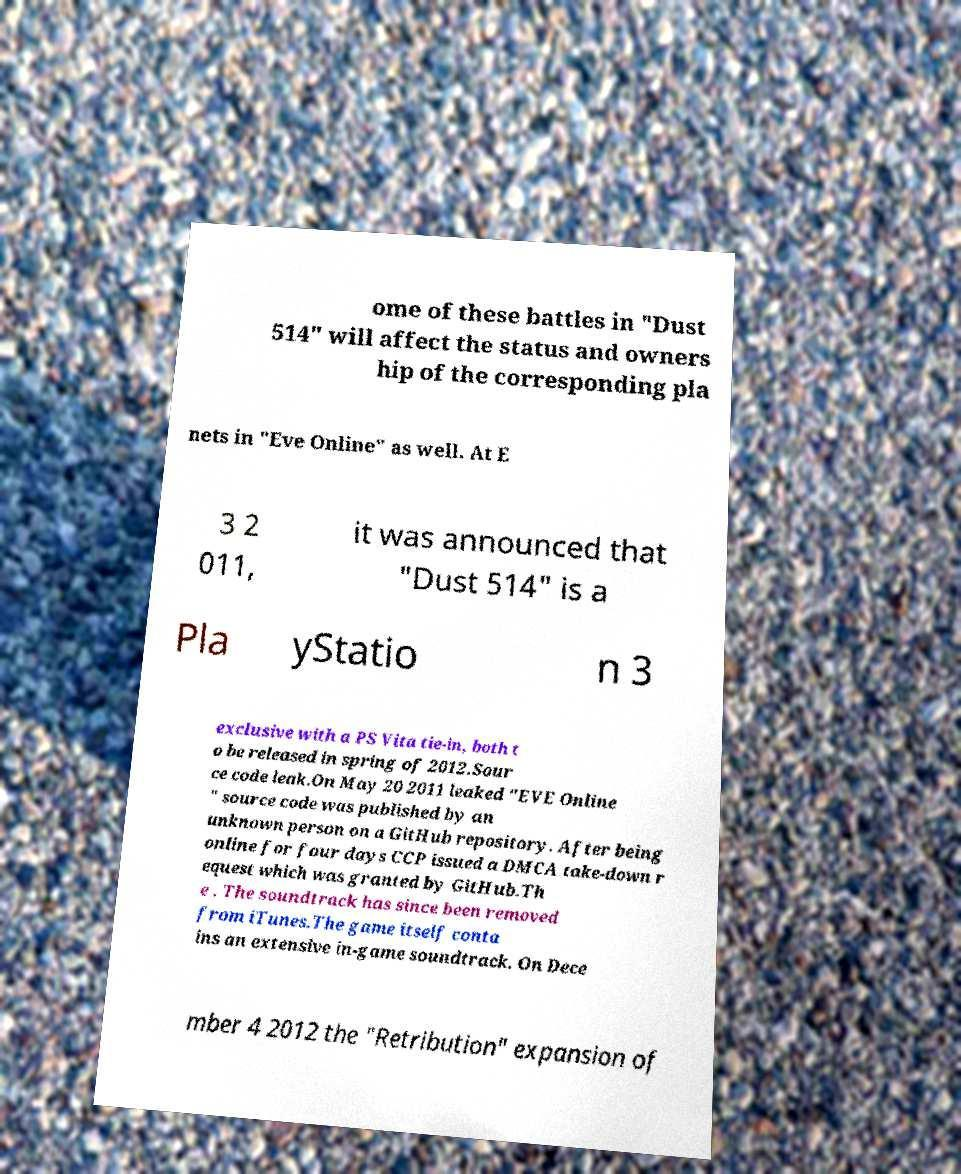Can you read and provide the text displayed in the image?This photo seems to have some interesting text. Can you extract and type it out for me? ome of these battles in "Dust 514" will affect the status and owners hip of the corresponding pla nets in "Eve Online" as well. At E 3 2 011, it was announced that "Dust 514" is a Pla yStatio n 3 exclusive with a PS Vita tie-in, both t o be released in spring of 2012.Sour ce code leak.On May 20 2011 leaked "EVE Online " source code was published by an unknown person on a GitHub repository. After being online for four days CCP issued a DMCA take-down r equest which was granted by GitHub.Th e . The soundtrack has since been removed from iTunes.The game itself conta ins an extensive in-game soundtrack. On Dece mber 4 2012 the "Retribution" expansion of 